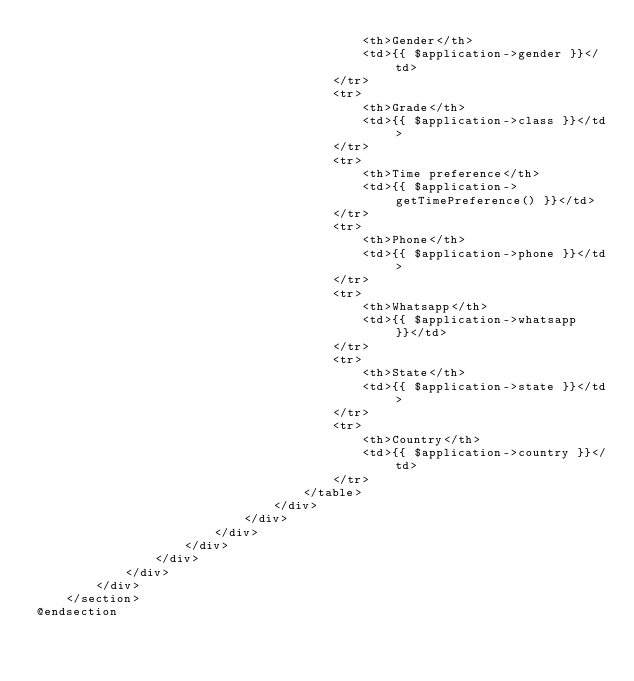<code> <loc_0><loc_0><loc_500><loc_500><_PHP_>                                            <th>Gender</th>
                                            <td>{{ $application->gender }}</td>
                                        </tr>
                                        <tr>
                                            <th>Grade</th>
                                            <td>{{ $application->class }}</td>
                                        </tr>
                                        <tr>
                                            <th>Time preference</th>
                                            <td>{{ $application->getTimePreference() }}</td>
                                        </tr>
                                        <tr>
                                            <th>Phone</th>
                                            <td>{{ $application->phone }}</td>
                                        </tr>
                                        <tr>
                                            <th>Whatsapp</th>
                                            <td>{{ $application->whatsapp }}</td>
                                        </tr>
                                        <tr>
                                            <th>State</th>
                                            <td>{{ $application->state }}</td>
                                        </tr>
                                        <tr>
                                            <th>Country</th>
                                            <td>{{ $application->country }}</td>
                                        </tr>
                                    </table>
                                </div>
                            </div>
                        </div>
                    </div>
                </div>
            </div>
        </div>
    </section>
@endsection</code> 